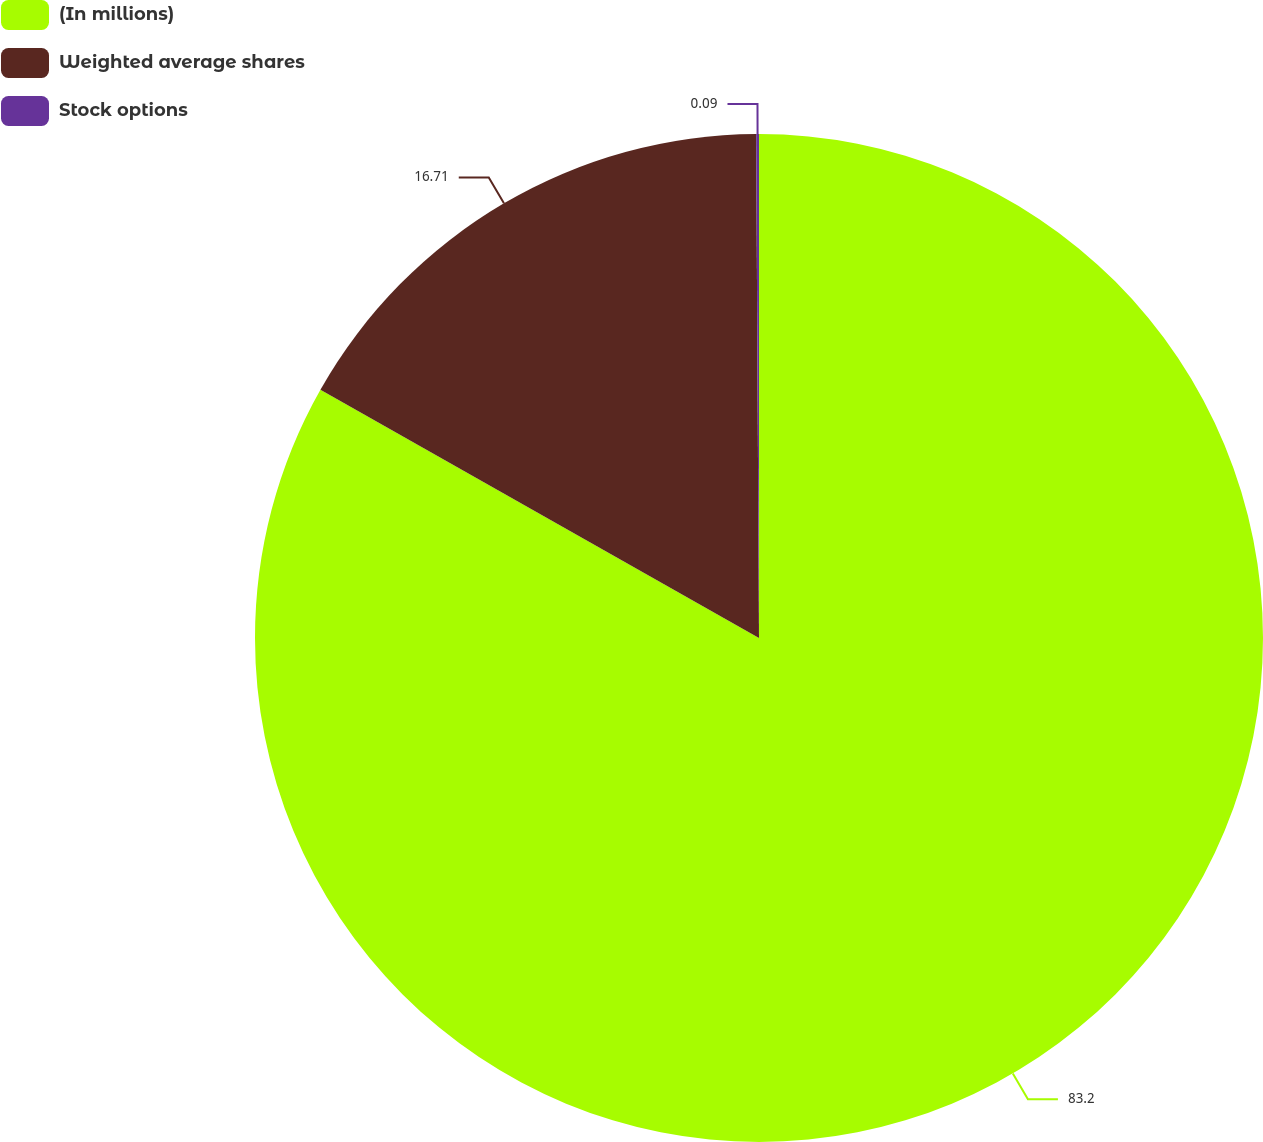Convert chart. <chart><loc_0><loc_0><loc_500><loc_500><pie_chart><fcel>(In millions)<fcel>Weighted average shares<fcel>Stock options<nl><fcel>83.2%<fcel>16.71%<fcel>0.09%<nl></chart> 